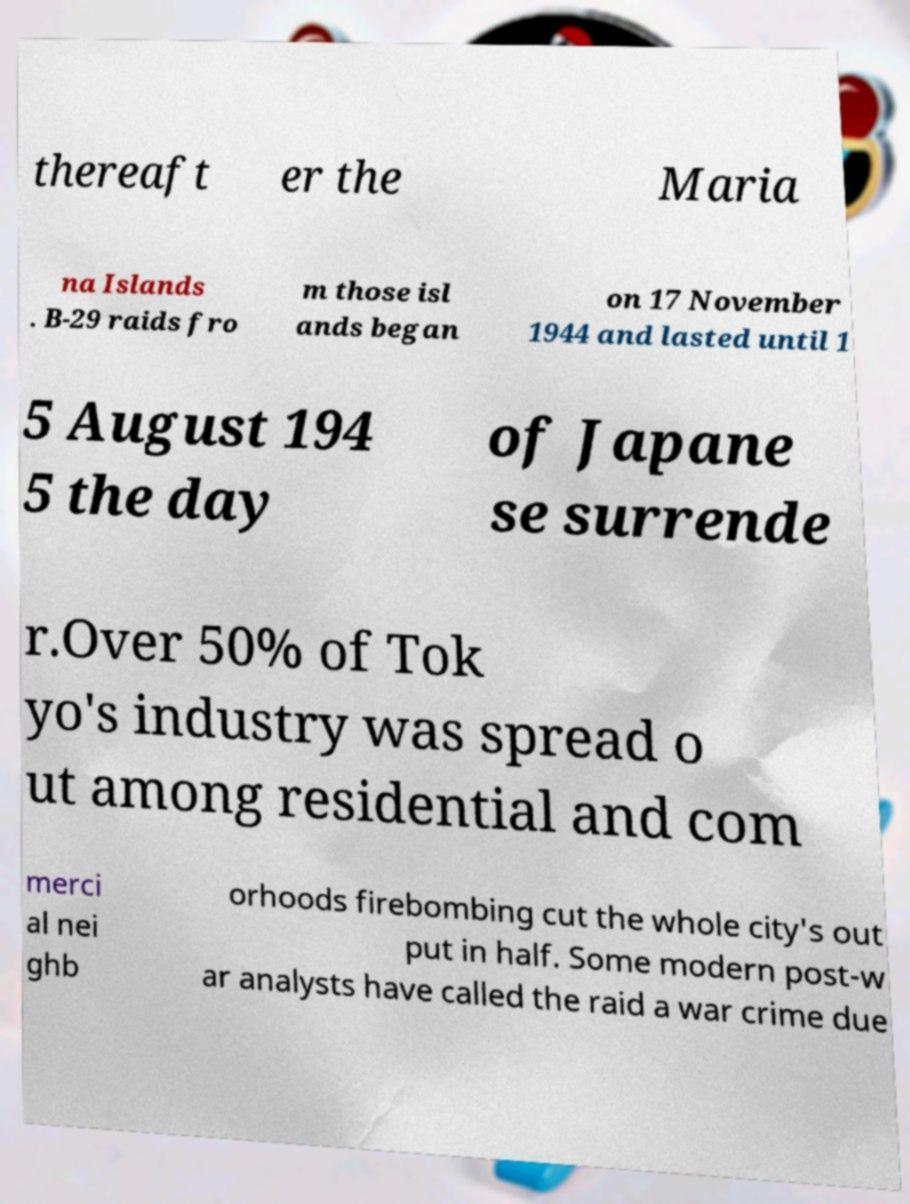Can you accurately transcribe the text from the provided image for me? thereaft er the Maria na Islands . B-29 raids fro m those isl ands began on 17 November 1944 and lasted until 1 5 August 194 5 the day of Japane se surrende r.Over 50% of Tok yo's industry was spread o ut among residential and com merci al nei ghb orhoods firebombing cut the whole city's out put in half. Some modern post-w ar analysts have called the raid a war crime due 